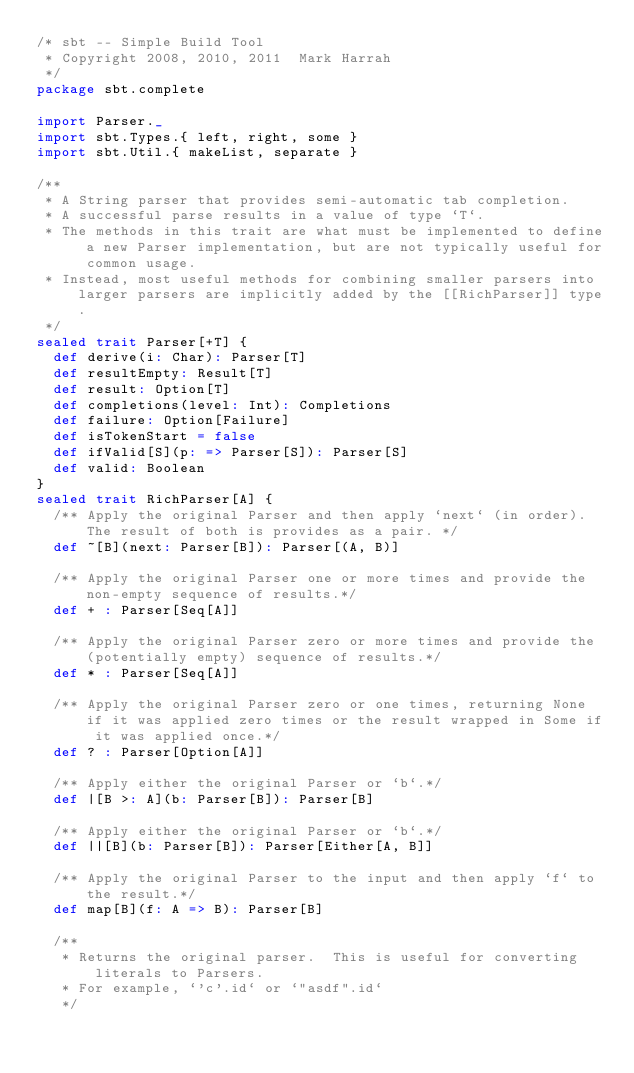<code> <loc_0><loc_0><loc_500><loc_500><_Scala_>/* sbt -- Simple Build Tool
 * Copyright 2008, 2010, 2011  Mark Harrah
 */
package sbt.complete

import Parser._
import sbt.Types.{ left, right, some }
import sbt.Util.{ makeList, separate }

/**
 * A String parser that provides semi-automatic tab completion.
 * A successful parse results in a value of type `T`.
 * The methods in this trait are what must be implemented to define a new Parser implementation, but are not typically useful for common usage.
 * Instead, most useful methods for combining smaller parsers into larger parsers are implicitly added by the [[RichParser]] type.
 */
sealed trait Parser[+T] {
  def derive(i: Char): Parser[T]
  def resultEmpty: Result[T]
  def result: Option[T]
  def completions(level: Int): Completions
  def failure: Option[Failure]
  def isTokenStart = false
  def ifValid[S](p: => Parser[S]): Parser[S]
  def valid: Boolean
}
sealed trait RichParser[A] {
  /** Apply the original Parser and then apply `next` (in order).  The result of both is provides as a pair. */
  def ~[B](next: Parser[B]): Parser[(A, B)]

  /** Apply the original Parser one or more times and provide the non-empty sequence of results.*/
  def + : Parser[Seq[A]]

  /** Apply the original Parser zero or more times and provide the (potentially empty) sequence of results.*/
  def * : Parser[Seq[A]]

  /** Apply the original Parser zero or one times, returning None if it was applied zero times or the result wrapped in Some if it was applied once.*/
  def ? : Parser[Option[A]]

  /** Apply either the original Parser or `b`.*/
  def |[B >: A](b: Parser[B]): Parser[B]

  /** Apply either the original Parser or `b`.*/
  def ||[B](b: Parser[B]): Parser[Either[A, B]]

  /** Apply the original Parser to the input and then apply `f` to the result.*/
  def map[B](f: A => B): Parser[B]

  /**
   * Returns the original parser.  This is useful for converting literals to Parsers.
   * For example, `'c'.id` or `"asdf".id`
   */</code> 